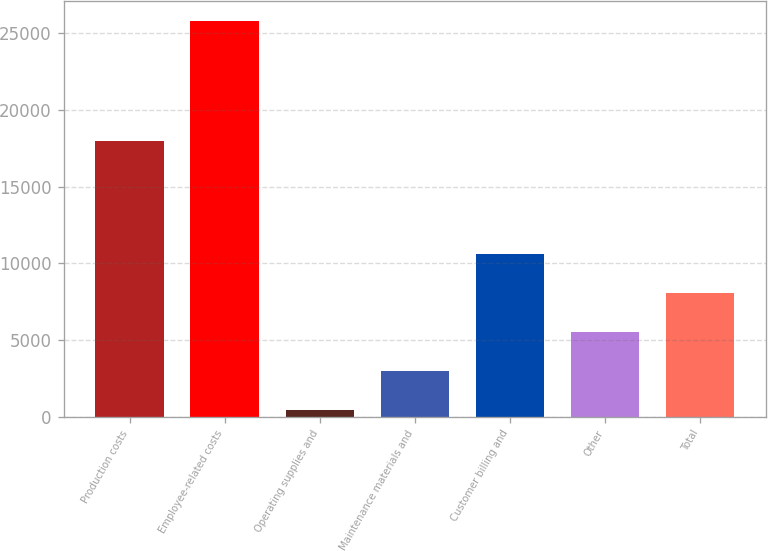Convert chart to OTSL. <chart><loc_0><loc_0><loc_500><loc_500><bar_chart><fcel>Production costs<fcel>Employee-related costs<fcel>Operating supplies and<fcel>Maintenance materials and<fcel>Customer billing and<fcel>Other<fcel>Total<nl><fcel>17987<fcel>25812<fcel>452<fcel>2988<fcel>10596<fcel>5524<fcel>8060<nl></chart> 